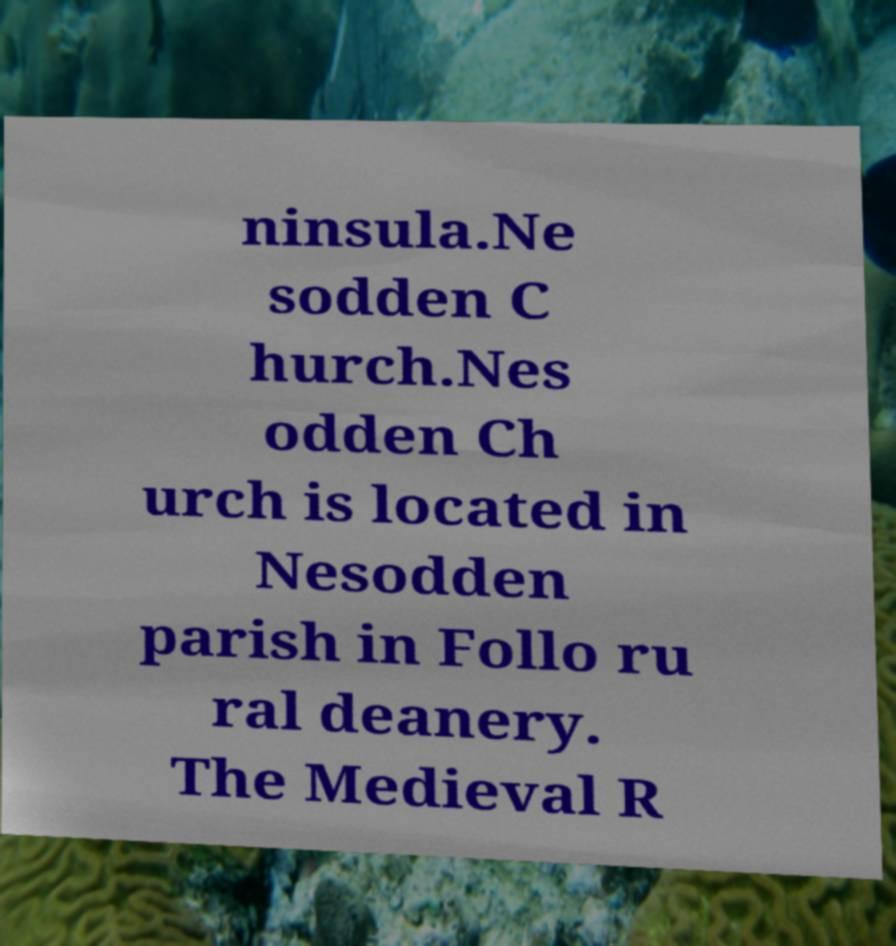Can you read and provide the text displayed in the image?This photo seems to have some interesting text. Can you extract and type it out for me? ninsula.Ne sodden C hurch.Nes odden Ch urch is located in Nesodden parish in Follo ru ral deanery. The Medieval R 